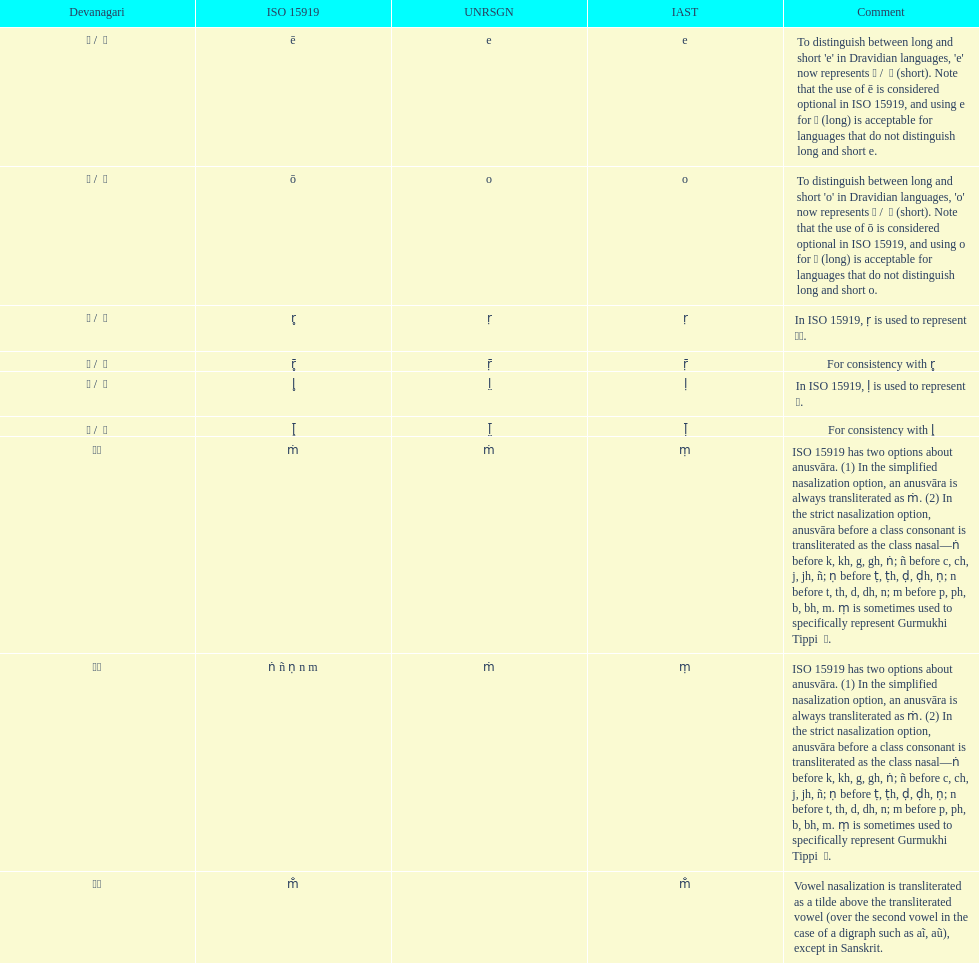Which devanagari transliteration is displayed at the beginning of the table? ए / े. 